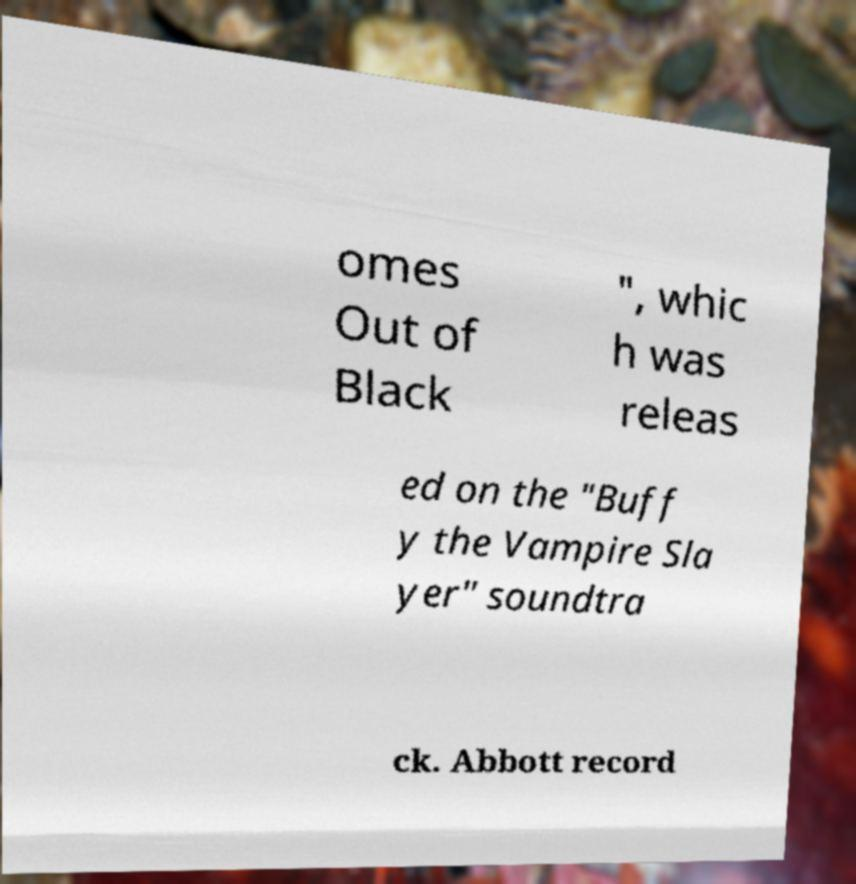Could you assist in decoding the text presented in this image and type it out clearly? omes Out of Black ", whic h was releas ed on the "Buff y the Vampire Sla yer" soundtra ck. Abbott record 